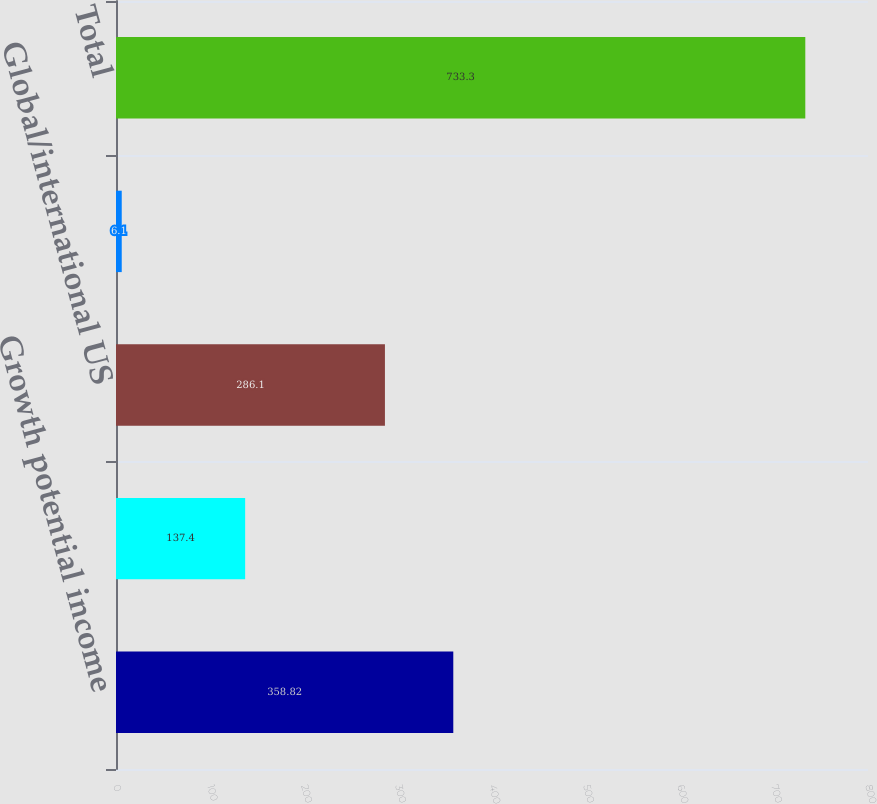<chart> <loc_0><loc_0><loc_500><loc_500><bar_chart><fcel>Growth potential income<fcel>Asset allocation balanced<fcel>Global/international US<fcel>Short-term liquid assets<fcel>Total<nl><fcel>358.82<fcel>137.4<fcel>286.1<fcel>6.1<fcel>733.3<nl></chart> 